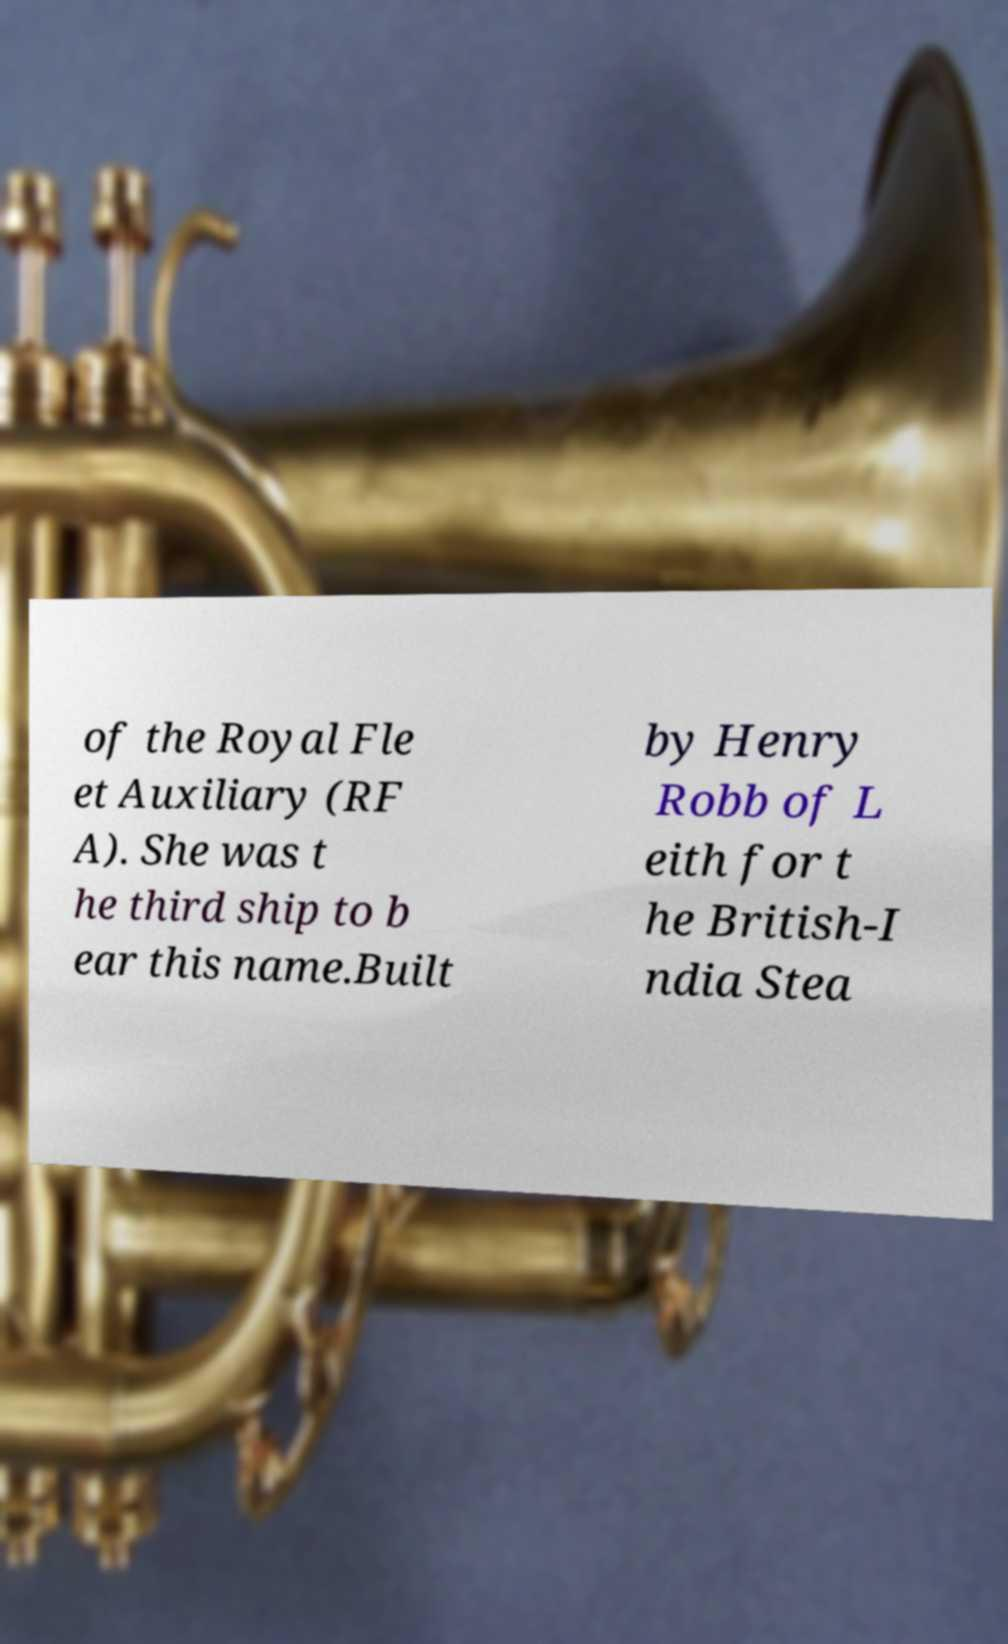Please read and relay the text visible in this image. What does it say? of the Royal Fle et Auxiliary (RF A). She was t he third ship to b ear this name.Built by Henry Robb of L eith for t he British-I ndia Stea 